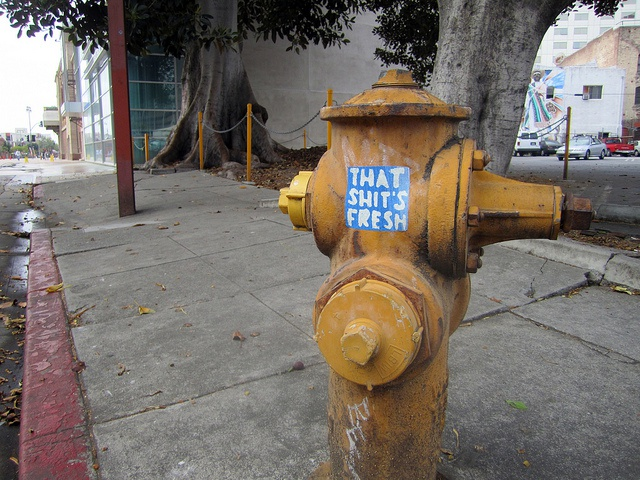Describe the objects in this image and their specific colors. I can see fire hydrant in white, maroon, olive, tan, and gray tones, car in white, lightgray, darkgray, and gray tones, car in white, lightgray, black, and darkgray tones, car in white, brown, gray, and black tones, and car in white, black, gray, and darkgray tones in this image. 